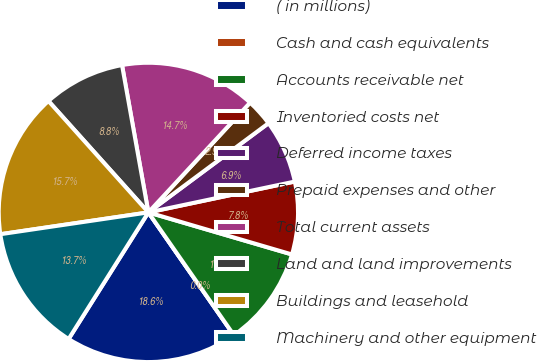<chart> <loc_0><loc_0><loc_500><loc_500><pie_chart><fcel>( in millions)<fcel>Cash and cash equivalents<fcel>Accounts receivable net<fcel>Inventoried costs net<fcel>Deferred income taxes<fcel>Prepaid expenses and other<fcel>Total current assets<fcel>Land and land improvements<fcel>Buildings and leasehold<fcel>Machinery and other equipment<nl><fcel>18.63%<fcel>0.0%<fcel>10.78%<fcel>7.84%<fcel>6.86%<fcel>2.94%<fcel>14.71%<fcel>8.82%<fcel>15.69%<fcel>13.72%<nl></chart> 